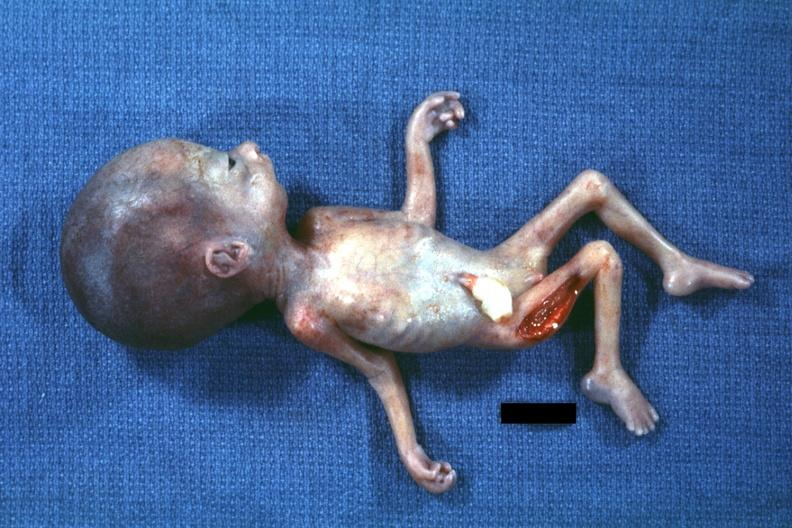does surface show photo of whole body showing head laterally with no chin?
Answer the question using a single word or phrase. No 